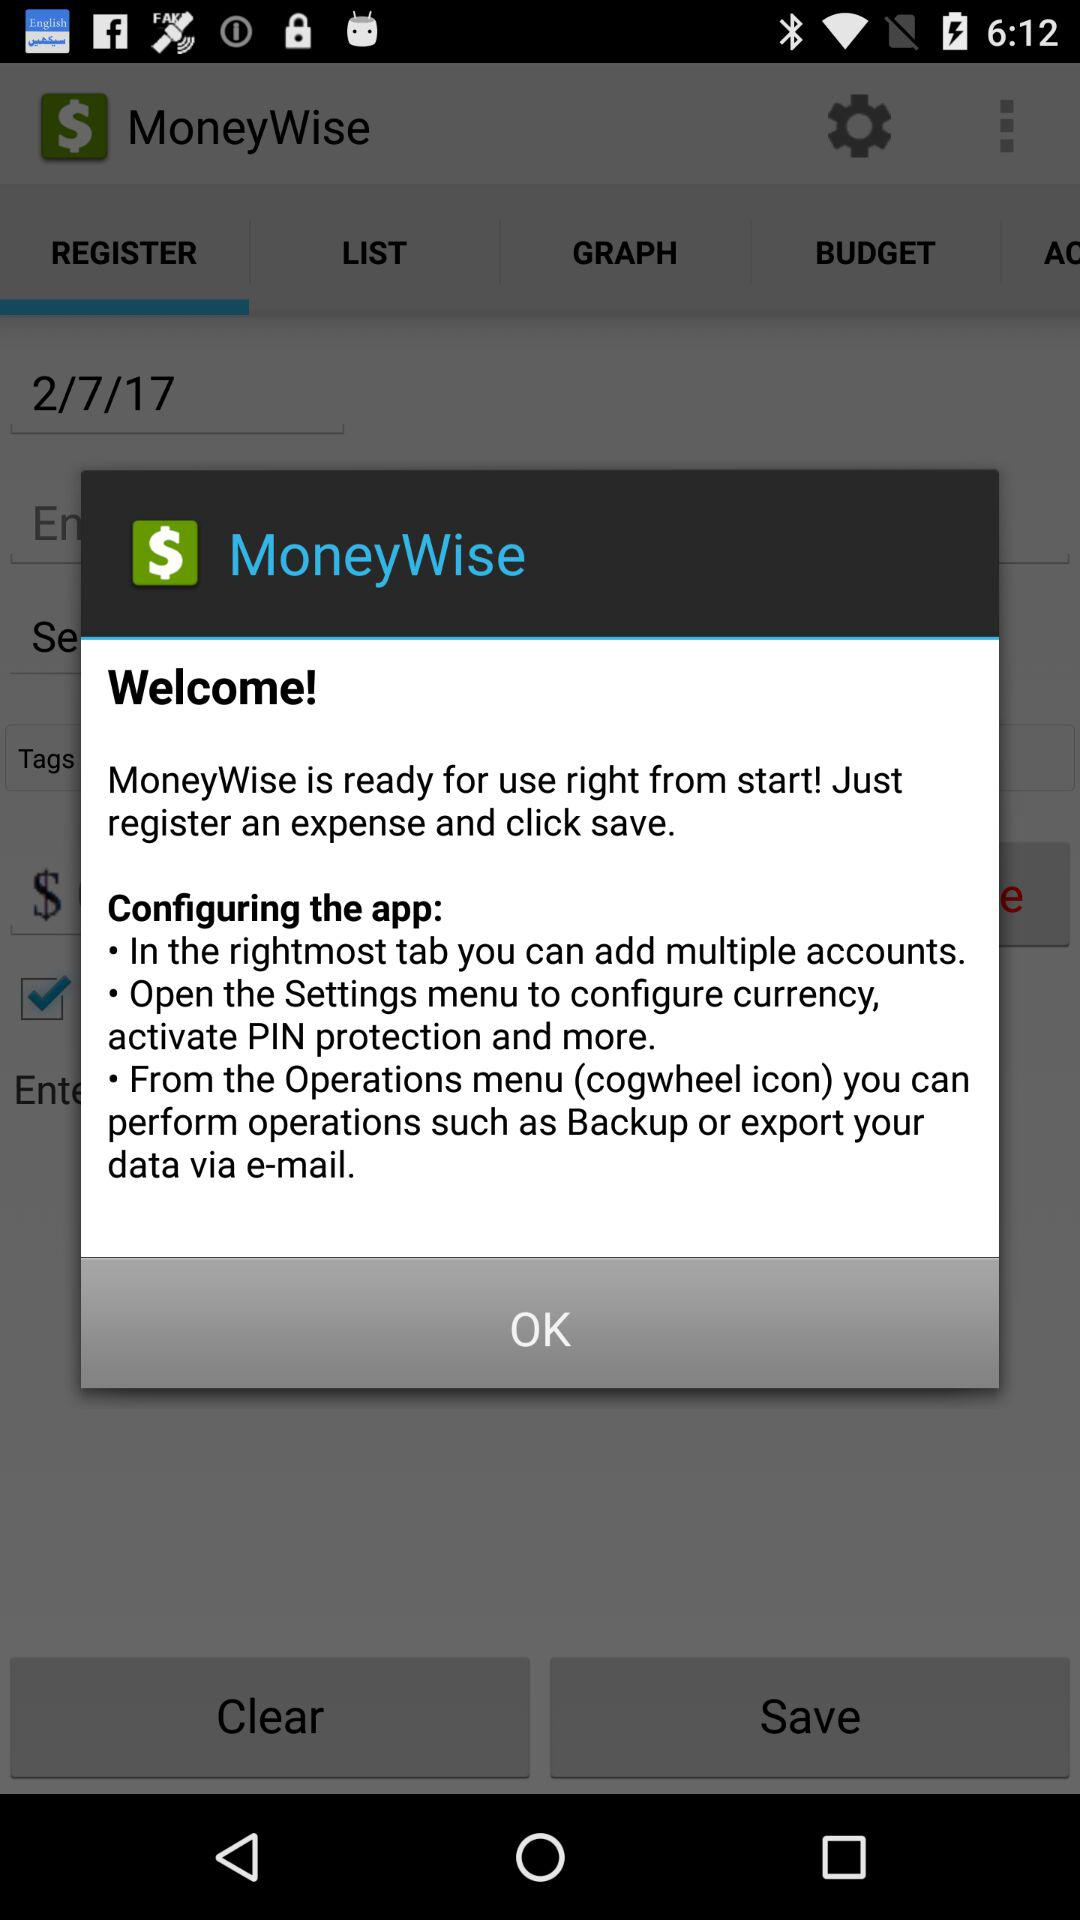What is the application name? The application name is "MoneyWise". 